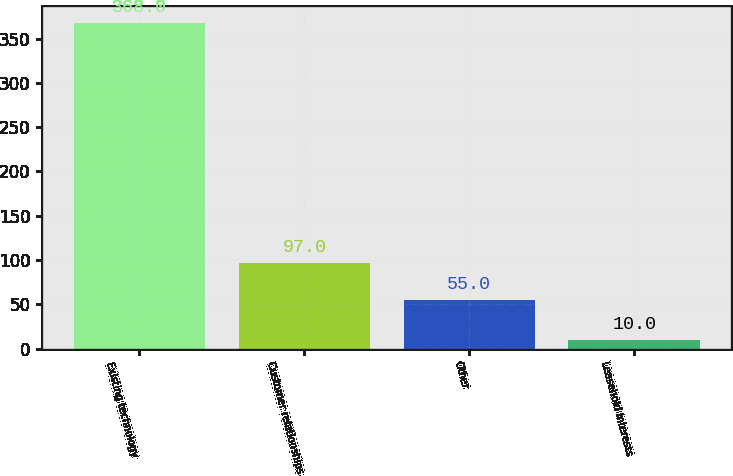Convert chart to OTSL. <chart><loc_0><loc_0><loc_500><loc_500><bar_chart><fcel>Existing technology<fcel>Customer relationships<fcel>Other<fcel>Leasehold interests<nl><fcel>368<fcel>97<fcel>55<fcel>10<nl></chart> 